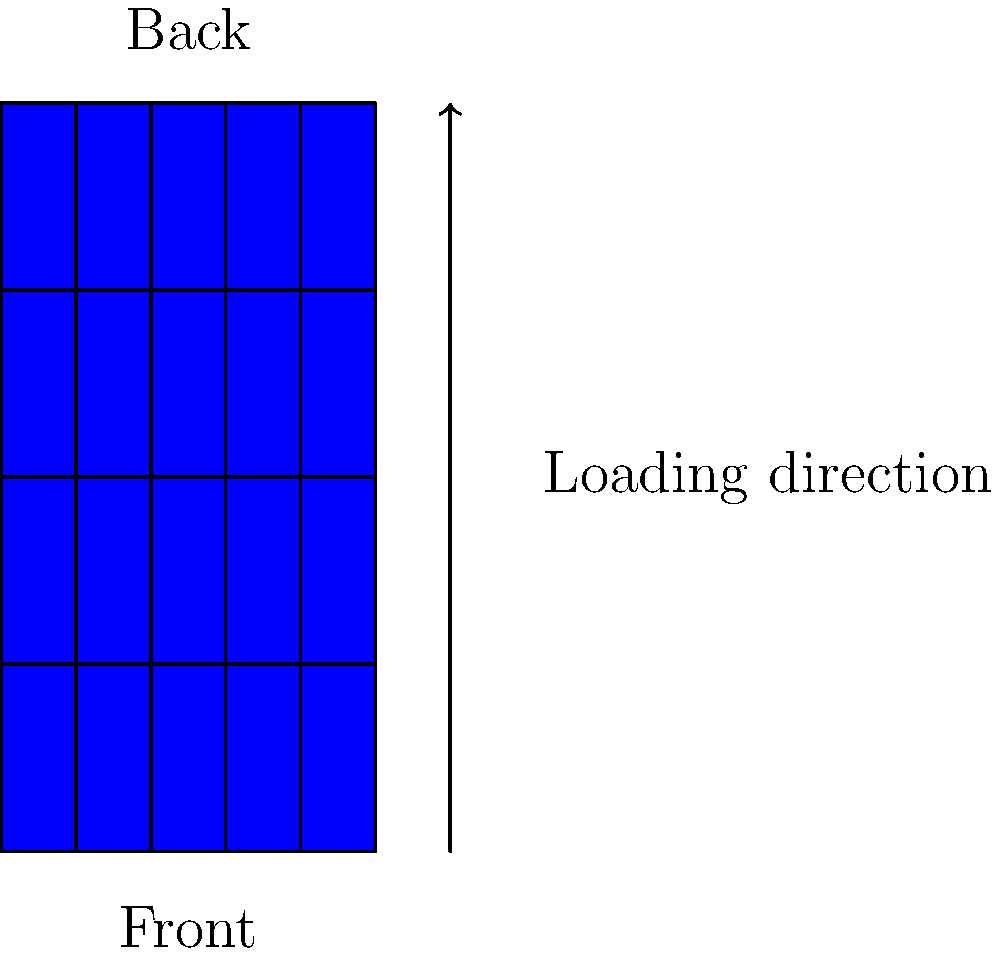Based on the diagram of a galley cart, which loading arrangement would be most efficient for meal service, assuming you serve from front to back of the aircraft? To determine the most efficient galley cart arrangement for meal service, we need to consider the following steps:

1. Observe the cart layout: The cart has 5 columns and 4 rows of meal trays.

2. Note the serving direction: We serve from front to back of the aircraft.

3. Identify the front and back of the cart: The diagram labels the front and back.

4. Consider the loading direction: The arrow indicates loading from bottom to top.

5. Analyze efficiency: The most efficient arrangement would minimize reaching and movement during service.

6. Optimal arrangement: Load the cart so that the first meals to be served are at the top-front of the cart, with subsequent meals following in order from top to bottom and front to back.

7. Implementation: Load the cart from bottom to top, with the last meals to be served at the bottom and the first meals at the top. Within each layer, place meals for the front of the aircraft closest to the front of the cart.

This arrangement allows flight attendants to serve meals smoothly from top to bottom and front to back, aligning with the aircraft's seating layout and minimizing unnecessary movements or reaching during service.
Answer: Load from bottom to top, last meals at bottom, first meals at top; within layers, front of aircraft meals towards cart front. 